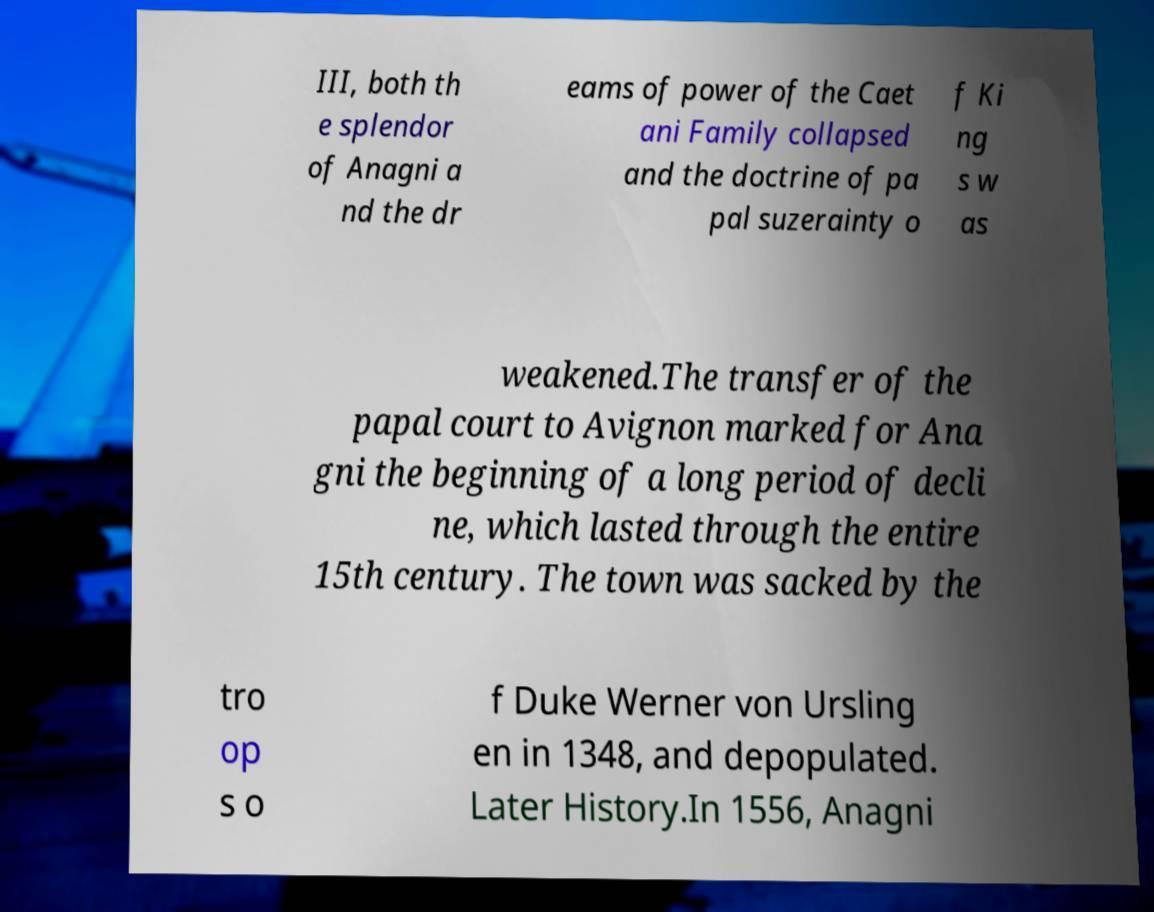I need the written content from this picture converted into text. Can you do that? III, both th e splendor of Anagni a nd the dr eams of power of the Caet ani Family collapsed and the doctrine of pa pal suzerainty o f Ki ng s w as weakened.The transfer of the papal court to Avignon marked for Ana gni the beginning of a long period of decli ne, which lasted through the entire 15th century. The town was sacked by the tro op s o f Duke Werner von Ursling en in 1348, and depopulated. Later History.In 1556, Anagni 